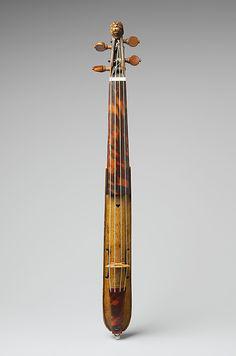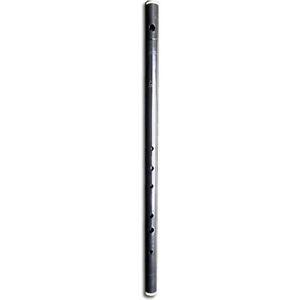The first image is the image on the left, the second image is the image on the right. Considering the images on both sides, is "There is exactly one flute." valid? Answer yes or no. Yes. The first image is the image on the left, the second image is the image on the right. Examine the images to the left and right. Is the description "There is a solid metal thing with no visible holes in the right image." accurate? Answer yes or no. No. 